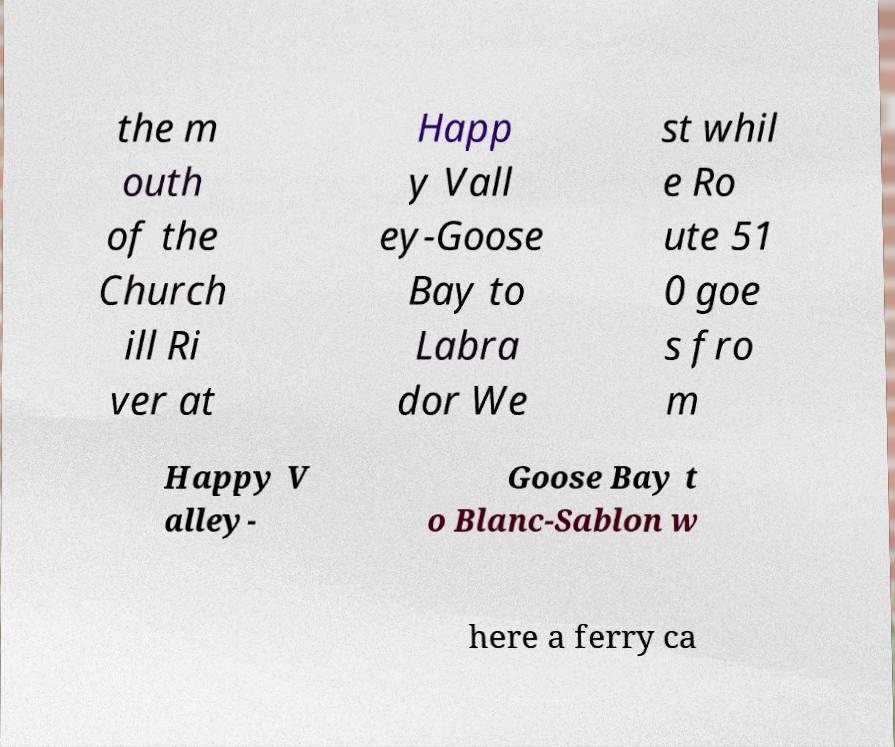What messages or text are displayed in this image? I need them in a readable, typed format. the m outh of the Church ill Ri ver at Happ y Vall ey-Goose Bay to Labra dor We st whil e Ro ute 51 0 goe s fro m Happy V alley- Goose Bay t o Blanc-Sablon w here a ferry ca 